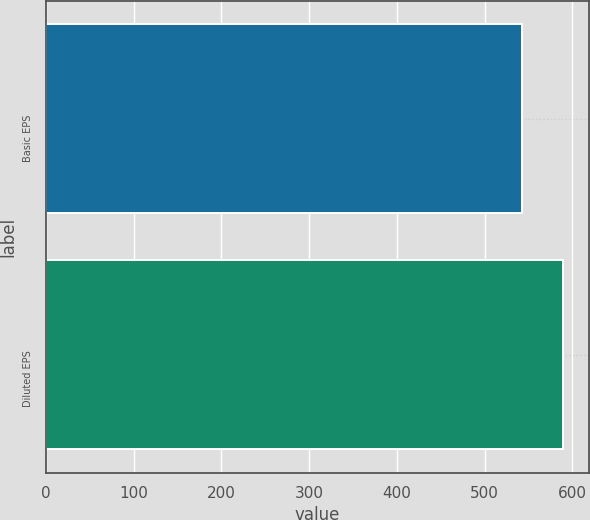Convert chart. <chart><loc_0><loc_0><loc_500><loc_500><bar_chart><fcel>Basic EPS<fcel>Diluted EPS<nl><fcel>542.7<fcel>589.1<nl></chart> 